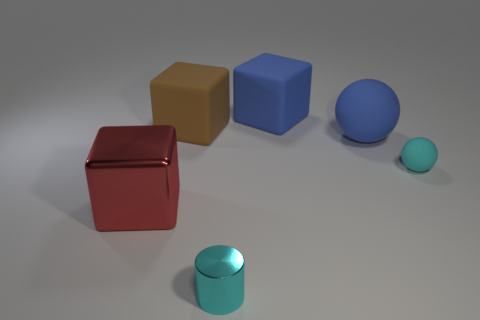What number of other metallic objects are the same color as the small metal object?
Provide a succinct answer. 0. Is the material of the small thing on the right side of the blue matte sphere the same as the big brown object?
Keep it short and to the point. Yes. The big metallic object has what shape?
Give a very brief answer. Cube. How many brown things are either small cylinders or big matte blocks?
Offer a terse response. 1. What number of other things are there of the same material as the cyan sphere
Offer a very short reply. 3. Does the big blue matte thing behind the large brown cube have the same shape as the tiny metallic object?
Make the answer very short. No. Is there a small green rubber cylinder?
Your answer should be very brief. No. Are there any other things that have the same shape as the small metallic object?
Offer a very short reply. No. Are there more blue spheres right of the cylinder than large purple shiny cubes?
Your answer should be compact. Yes. There is a large blue matte block; are there any large red objects behind it?
Provide a short and direct response. No. 